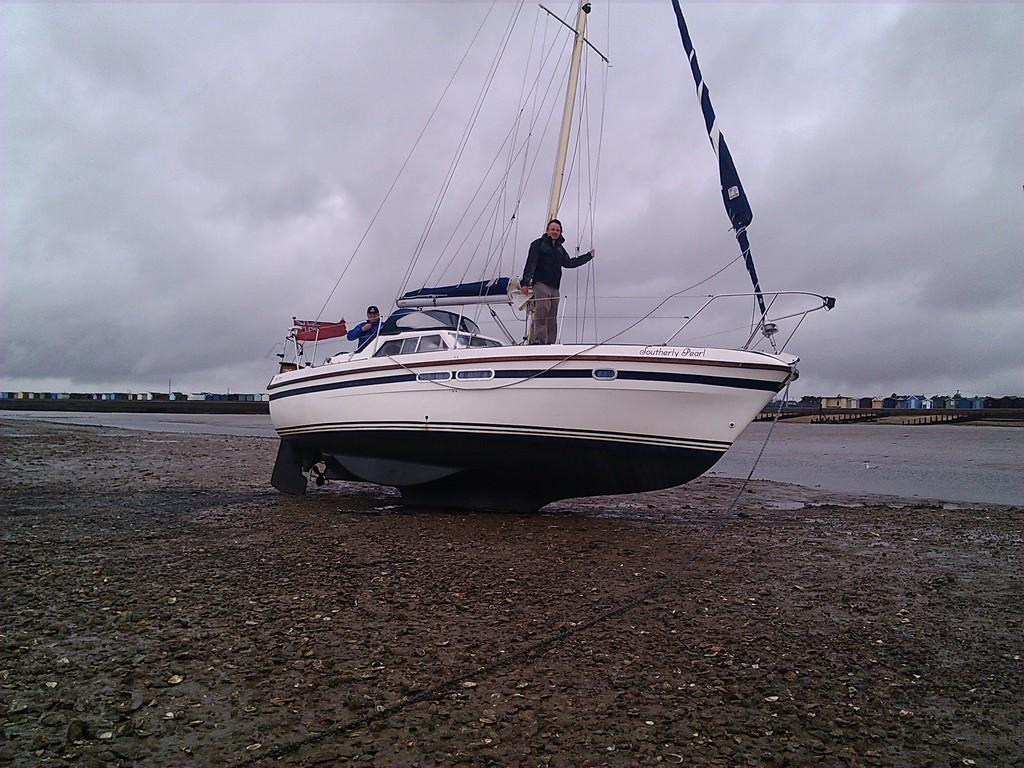What type of boat is in the image? There is a black and white boat in the image. Where is the boat located? The boat is on land. How many people are on the boat? There are two people standing on the boat. What company is responsible for the bit of technology on the boat? There is no technology or company mentioned in the image; it only features a black and white boat with two people standing on it. 